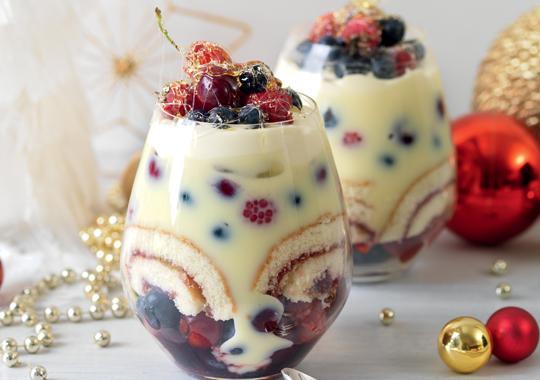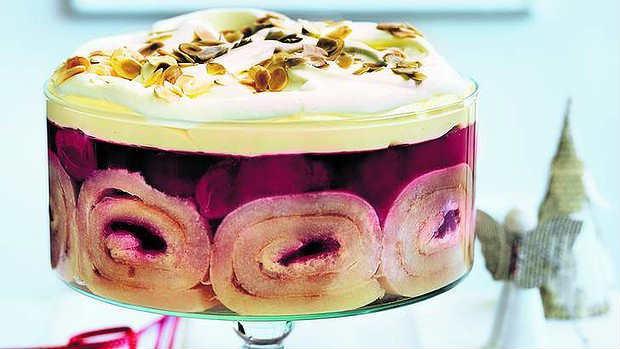The first image is the image on the left, the second image is the image on the right. Considering the images on both sides, is "An image shows a dessert garnished with red fruit that features jelly roll slices around the outer edge." valid? Answer yes or no. Yes. 